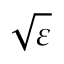Convert formula to latex. <formula><loc_0><loc_0><loc_500><loc_500>\sqrt { \varepsilon }</formula> 